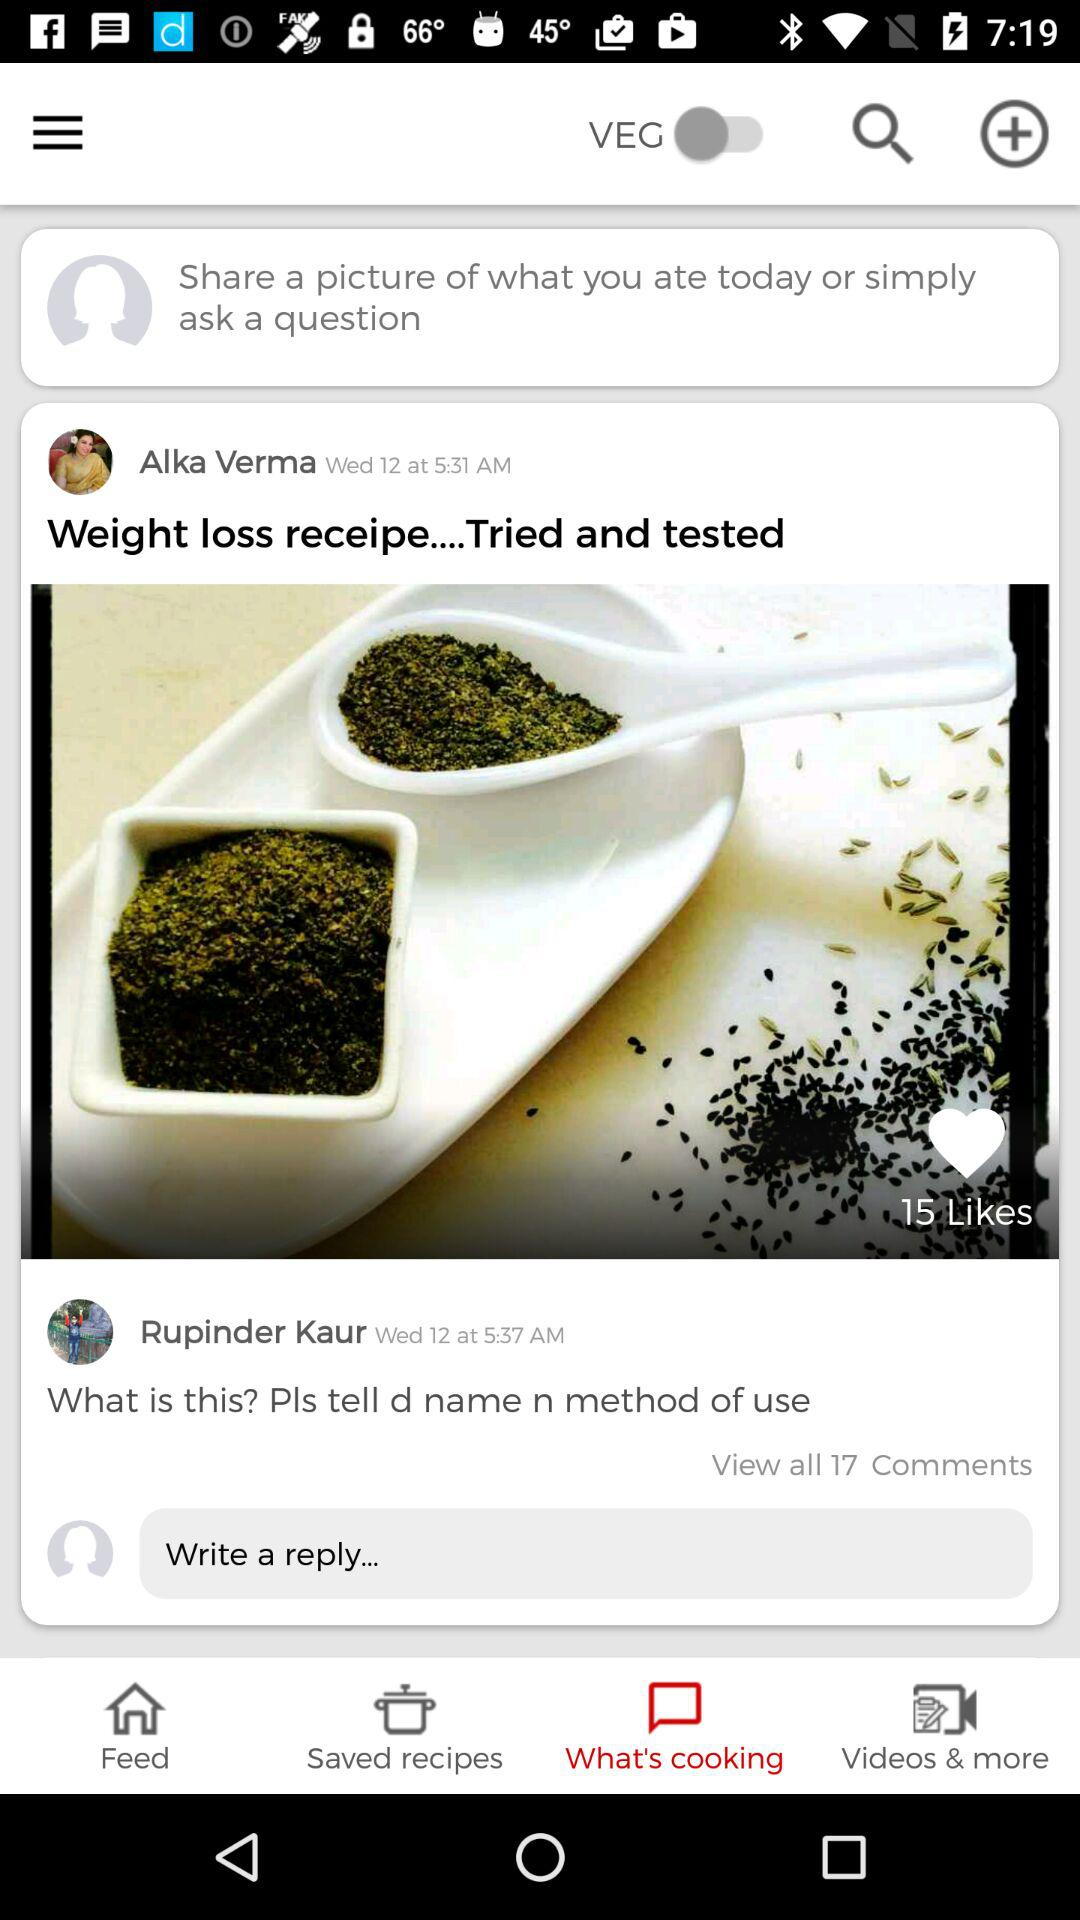How many comments are available? There are 17 comments available. 